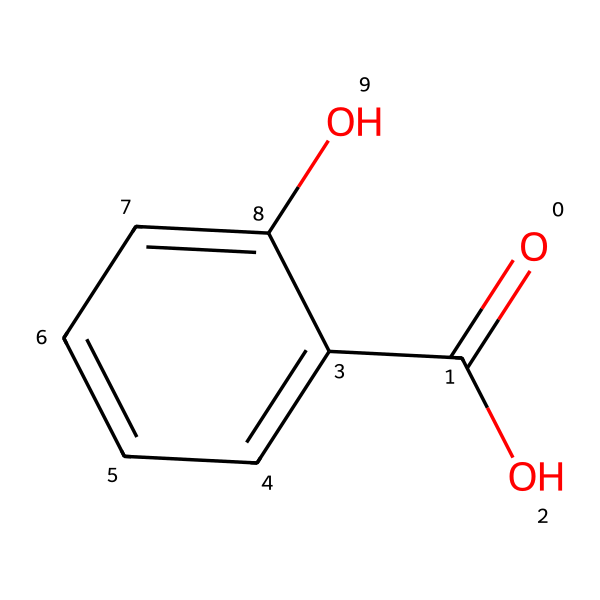how many carbon atoms are present in salicylic acid? The SMILES representation contains a benzene ring, which consists of six carbon atoms, and a carboxylic acid group, which contains one additional carbon atom. Thus, the total number of carbon atoms is seven.
Answer: seven what functional groups are present in salicylic acid? Looking at the structure, salicylic acid has two main functional groups: a carboxylic acid group (from the -COOH) and a hydroxyl group (from the -OH).
Answer: carboxylic acid and hydroxyl what type of acid is salicylic acid? Salicylic acid is classified as a weak acid due to its incomplete dissociation in water. Its structure contributes to this property.
Answer: weak acid which part of salicylic acid is responsible for its anti-inflammatory properties? The presence of the carboxylic acid group (-COOH) is critical, as it allows salicylic acid to interact with biochemical pathways that reduce inflammation, particularly by inhibiting enzymes similar to aspirin.
Answer: carboxylic acid group how many hydroxyl groups are present in salicylic acid? The structure clearly shows one -OH (hydroxyl) group attached to the benzene ring. Thus, there is only one hydroxyl group in salicylic acid.
Answer: one how does salicylic acid contribute to treating tennis elbow? Salicylic acid has anti-inflammatory properties, which help reduce swelling and pain in joints like the elbow, making it effective for treating tennis elbow and similar injuries.
Answer: anti-inflammatory properties 